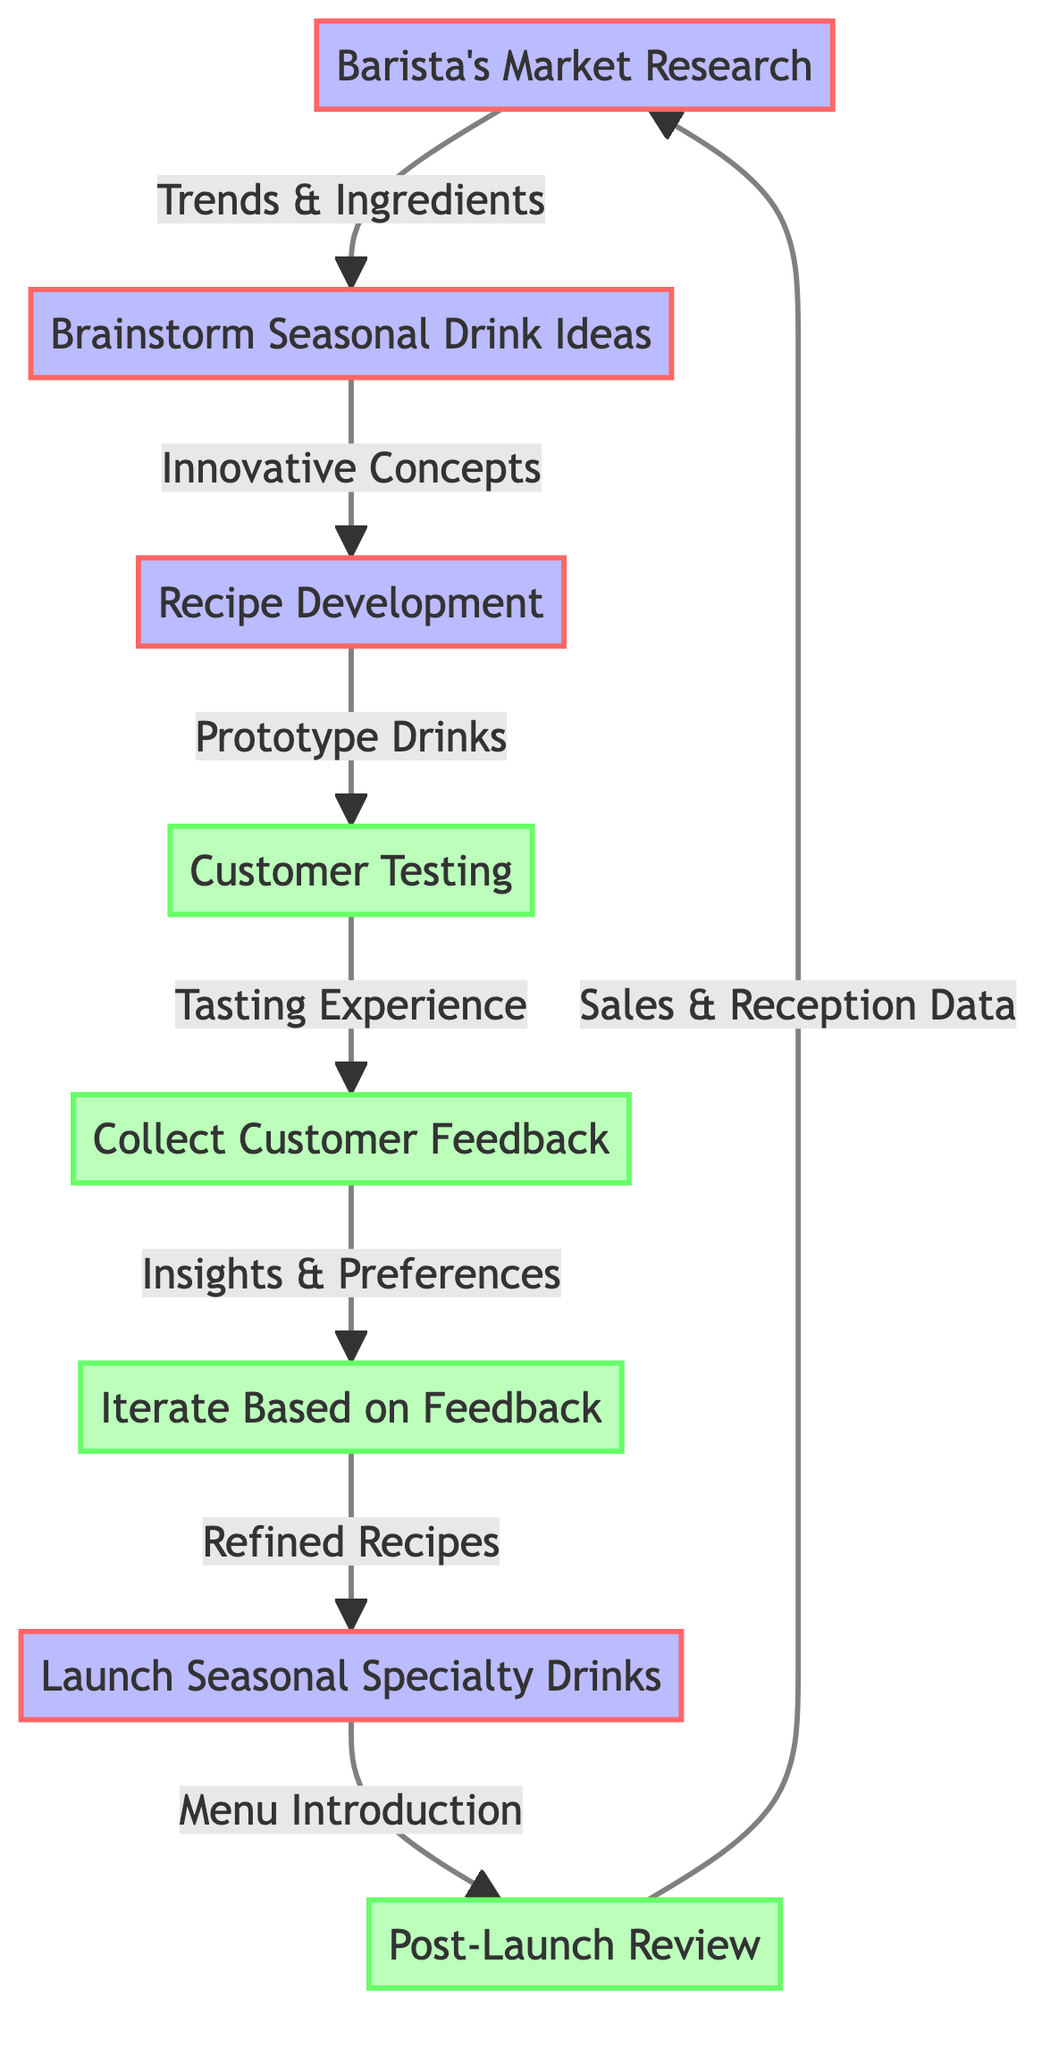What is the starting point of the process? The process begins at the node labeled "Barista's Market Research," which is the first node in the diagram.
Answer: Barista's Market Research How many nodes are in the diagram? Counting all unique circular nodes displayed in the diagram yields a total of 8 nodes representing different steps in the seasonal specialty drink development process.
Answer: 8 What is the final step before the process loops back? The last step before returning to the starting point is "Post-Launch Review," providing an evaluation of the seasonal drinks after launch.
Answer: Post-Launch Review Which node receives feedback from customers? The node "Collect Customer Feedback" specifically focuses on gathering insights from customers' tasting experiences after testing the prototype drinks.
Answer: Collect Customer Feedback What influences the recipe development stage? The recipe development stage is influenced by the ideas generated during the "Brainstorm Seasonal Drink Ideas" stage, indicating a collaborative effort in creating innovative concepts.
Answer: Innovative Concepts Which two processes are directly connected by customer feedback? "Customer Testing" and "Collect Customer Feedback" are directly connected, as customers provide feedback based on their tasting experiences after testing the prototype drinks.
Answer: Customer Testing and Collect Customer Feedback What is the purpose of the "Post-Launch Review"? The "Post-Launch Review" serves as an evaluation phase to assess sales performance and customer reception, allowing for possible future improvements to the menu.
Answer: Evaluate sales and customer reception Which node leads to the launching of seasonal specialty drinks? The "Iterate Based on Feedback" node leads directly to the "Launch Seasonal Specialty Drinks" node, indicating that refinement based on feedback is necessary before the launch.
Answer: Launch Seasonal Specialty Drinks 